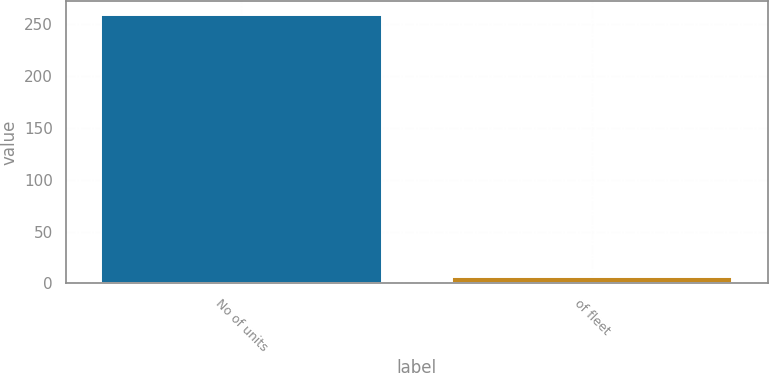<chart> <loc_0><loc_0><loc_500><loc_500><bar_chart><fcel>No of units<fcel>of fleet<nl><fcel>259<fcel>6<nl></chart> 